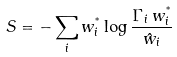Convert formula to latex. <formula><loc_0><loc_0><loc_500><loc_500>S = - \sum _ { i } w _ { i } ^ { ^ { * } } \log \frac { \Gamma _ { i } \, w _ { i } ^ { ^ { * } } } { \hat { w } _ { i } }</formula> 